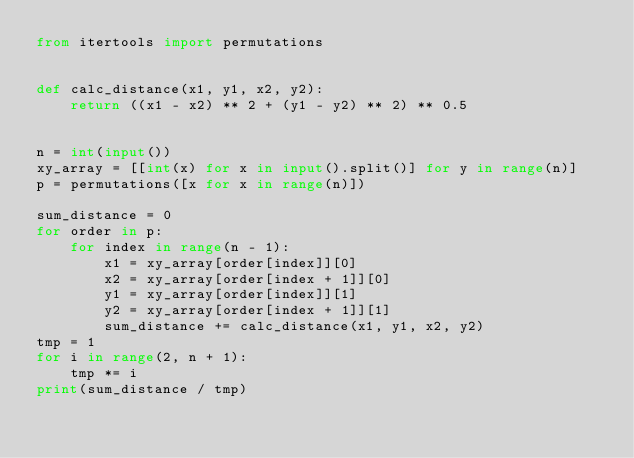<code> <loc_0><loc_0><loc_500><loc_500><_Python_>from itertools import permutations


def calc_distance(x1, y1, x2, y2):
    return ((x1 - x2) ** 2 + (y1 - y2) ** 2) ** 0.5


n = int(input())
xy_array = [[int(x) for x in input().split()] for y in range(n)]
p = permutations([x for x in range(n)])

sum_distance = 0
for order in p:
    for index in range(n - 1):
        x1 = xy_array[order[index]][0]
        x2 = xy_array[order[index + 1]][0]
        y1 = xy_array[order[index]][1]
        y2 = xy_array[order[index + 1]][1]
        sum_distance += calc_distance(x1, y1, x2, y2)
tmp = 1
for i in range(2, n + 1):
    tmp *= i
print(sum_distance / tmp)
</code> 